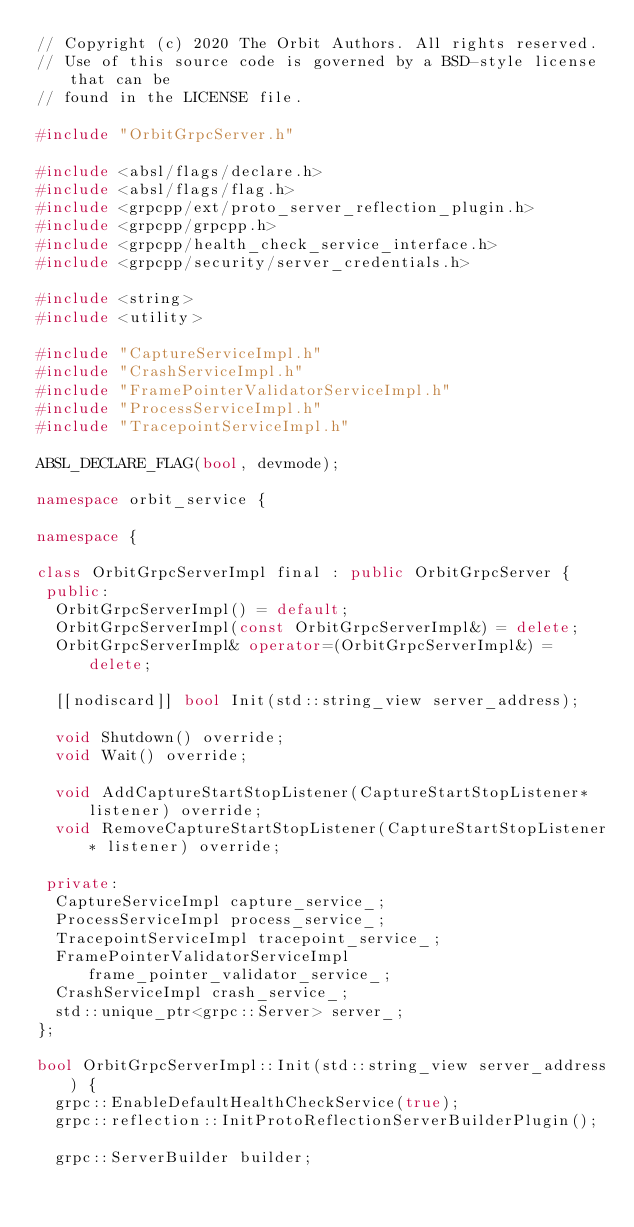Convert code to text. <code><loc_0><loc_0><loc_500><loc_500><_C++_>// Copyright (c) 2020 The Orbit Authors. All rights reserved.
// Use of this source code is governed by a BSD-style license that can be
// found in the LICENSE file.

#include "OrbitGrpcServer.h"

#include <absl/flags/declare.h>
#include <absl/flags/flag.h>
#include <grpcpp/ext/proto_server_reflection_plugin.h>
#include <grpcpp/grpcpp.h>
#include <grpcpp/health_check_service_interface.h>
#include <grpcpp/security/server_credentials.h>

#include <string>
#include <utility>

#include "CaptureServiceImpl.h"
#include "CrashServiceImpl.h"
#include "FramePointerValidatorServiceImpl.h"
#include "ProcessServiceImpl.h"
#include "TracepointServiceImpl.h"

ABSL_DECLARE_FLAG(bool, devmode);

namespace orbit_service {

namespace {

class OrbitGrpcServerImpl final : public OrbitGrpcServer {
 public:
  OrbitGrpcServerImpl() = default;
  OrbitGrpcServerImpl(const OrbitGrpcServerImpl&) = delete;
  OrbitGrpcServerImpl& operator=(OrbitGrpcServerImpl&) = delete;

  [[nodiscard]] bool Init(std::string_view server_address);

  void Shutdown() override;
  void Wait() override;

  void AddCaptureStartStopListener(CaptureStartStopListener* listener) override;
  void RemoveCaptureStartStopListener(CaptureStartStopListener* listener) override;

 private:
  CaptureServiceImpl capture_service_;
  ProcessServiceImpl process_service_;
  TracepointServiceImpl tracepoint_service_;
  FramePointerValidatorServiceImpl frame_pointer_validator_service_;
  CrashServiceImpl crash_service_;
  std::unique_ptr<grpc::Server> server_;
};

bool OrbitGrpcServerImpl::Init(std::string_view server_address) {
  grpc::EnableDefaultHealthCheckService(true);
  grpc::reflection::InitProtoReflectionServerBuilderPlugin();

  grpc::ServerBuilder builder;
</code> 